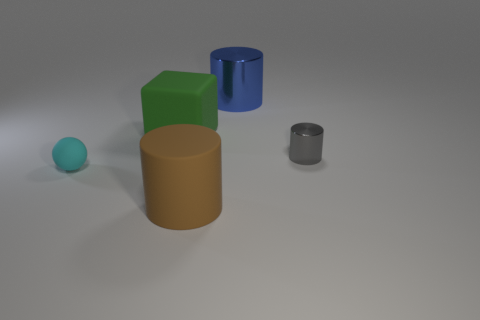There is a big blue object; is it the same shape as the metallic object in front of the blue shiny object?
Your response must be concise. Yes. What number of other things are the same size as the brown matte thing?
Provide a succinct answer. 2. Are there more yellow rubber objects than gray objects?
Your answer should be very brief. No. What number of large things are both in front of the cyan ball and behind the large cube?
Keep it short and to the point. 0. The large rubber object that is behind the rubber thing that is in front of the small object that is left of the brown cylinder is what shape?
Your answer should be very brief. Cube. Is there anything else that has the same shape as the green matte object?
Offer a very short reply. No. How many cubes are matte things or small cyan rubber objects?
Provide a short and direct response. 1. What material is the small object on the left side of the metallic thing that is in front of the shiny cylinder that is behind the small gray metal cylinder?
Ensure brevity in your answer.  Rubber. Does the brown thing have the same size as the matte ball?
Your response must be concise. No. What is the shape of the other thing that is the same material as the gray object?
Your answer should be very brief. Cylinder. 